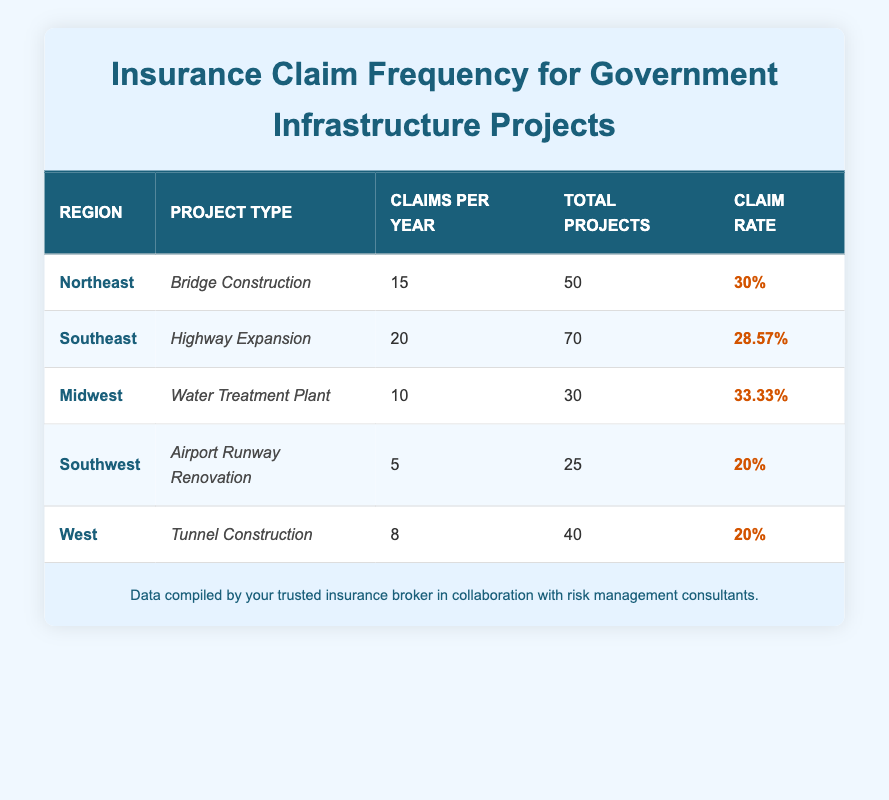What is the claim frequency for Bridge Construction in the Northeast region? Referring to the table, under the Northeast region and the Bridge Construction project type, the Claims Per Year is 15, Total Projects is 50, and the Claim Rate is 30%.
Answer: 15 claims per year Which region has the highest claim rate, and what is that rate? Examining the table, the Midwest region shows a Claim Rate of 33.33%, which is the highest among all regions listed.
Answer: Midwest, 33.33% What is the total number of projects reported across all regions? Summing the Total Projects from each region: 50 (Northeast) + 70 (Southeast) + 30 (Midwest) + 25 (Southwest) + 40 (West) equals 215.
Answer: 215 total projects Does the Southwest region have a claim rate higher than 25%? The Claim Rate for the Southwest region is 20%, which is lower than 25%; therefore, the statement is false.
Answer: No Which project type has the lowest claims per year and what is that number? Looking at the Claims Per Year column, the Airport Runway Renovation project type in the Southwest region has the lowest at 5 claims per year.
Answer: 5 claims per year What is the average claim rate for all regions listed? To calculate the average Claim Rate, first, convert the percentages to decimals: 30% (0.30) + 28.57% (0.2857) + 33.33% (0.3333) + 20% (0.20) + 20% (0.20) = 1.3687. Dividing by 5 gives an average of approximately 27.374%.
Answer: 27.37% Is the claim frequency for Tunnel Construction in the West higher than the claim frequency for Airport Runway Renovation in the Southwest? The Claims Per Year for Tunnel Construction (8) is greater than that for Airport Runway Renovation (5), confirming that the claim frequency for Tunnel Construction is higher.
Answer: Yes What is the difference in claims per year between the Southeast and the Midwest regions? The Southeast region has 20 Claims Per Year and the Midwest has 10. The difference is 20 - 10 = 10 claims per year.
Answer: 10 claims per year 